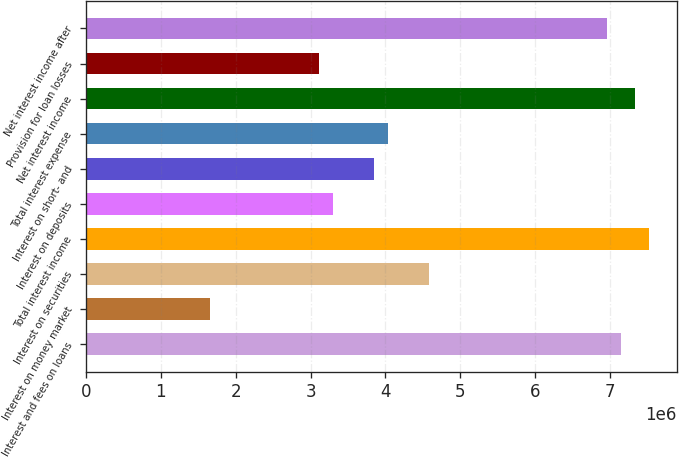<chart> <loc_0><loc_0><loc_500><loc_500><bar_chart><fcel>Interest and fees on loans<fcel>Interest on money market<fcel>Interest on securities<fcel>Total interest income<fcel>Interest on deposits<fcel>Interest on short- and<fcel>Total interest expense<fcel>Net interest income<fcel>Provision for loan losses<fcel>Net interest income after<nl><fcel>7.15053e+06<fcel>1.65012e+06<fcel>4.58368e+06<fcel>7.51723e+06<fcel>3.30025e+06<fcel>3.85029e+06<fcel>4.03363e+06<fcel>7.33388e+06<fcel>3.1169e+06<fcel>6.96719e+06<nl></chart> 